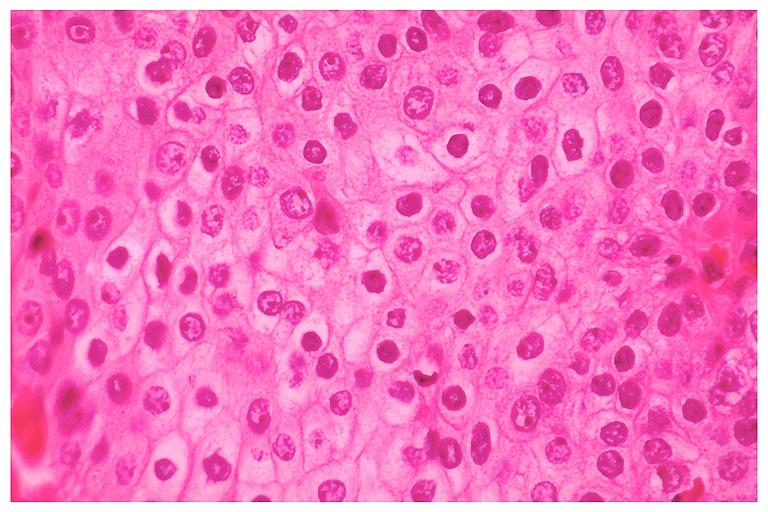does sugar coated show mucoepidermoid carcinoma?
Answer the question using a single word or phrase. No 